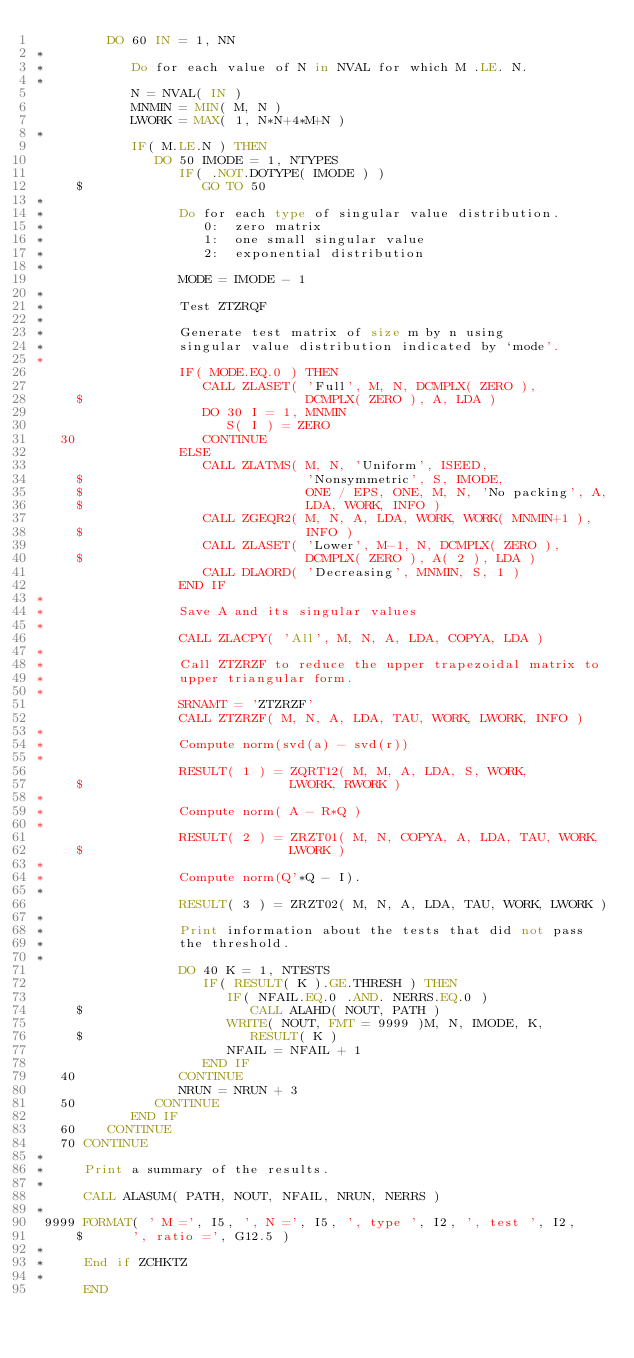<code> <loc_0><loc_0><loc_500><loc_500><_FORTRAN_>         DO 60 IN = 1, NN
*
*           Do for each value of N in NVAL for which M .LE. N.
*
            N = NVAL( IN )
            MNMIN = MIN( M, N )
            LWORK = MAX( 1, N*N+4*M+N )
*
            IF( M.LE.N ) THEN
               DO 50 IMODE = 1, NTYPES
                  IF( .NOT.DOTYPE( IMODE ) )
     $               GO TO 50
*
*                 Do for each type of singular value distribution.
*                    0:  zero matrix
*                    1:  one small singular value
*                    2:  exponential distribution
*
                  MODE = IMODE - 1
*
*                 Test ZTZRQF
*
*                 Generate test matrix of size m by n using
*                 singular value distribution indicated by `mode'.
*
                  IF( MODE.EQ.0 ) THEN
                     CALL ZLASET( 'Full', M, N, DCMPLX( ZERO ),
     $                            DCMPLX( ZERO ), A, LDA )
                     DO 30 I = 1, MNMIN
                        S( I ) = ZERO
   30                CONTINUE
                  ELSE
                     CALL ZLATMS( M, N, 'Uniform', ISEED,
     $                            'Nonsymmetric', S, IMODE,
     $                            ONE / EPS, ONE, M, N, 'No packing', A,
     $                            LDA, WORK, INFO )
                     CALL ZGEQR2( M, N, A, LDA, WORK, WORK( MNMIN+1 ),
     $                            INFO )
                     CALL ZLASET( 'Lower', M-1, N, DCMPLX( ZERO ),
     $                            DCMPLX( ZERO ), A( 2 ), LDA )
                     CALL DLAORD( 'Decreasing', MNMIN, S, 1 )
                  END IF
*
*                 Save A and its singular values
*
                  CALL ZLACPY( 'All', M, N, A, LDA, COPYA, LDA )
*
*                 Call ZTZRZF to reduce the upper trapezoidal matrix to
*                 upper triangular form.
*
                  SRNAMT = 'ZTZRZF'
                  CALL ZTZRZF( M, N, A, LDA, TAU, WORK, LWORK, INFO )
*
*                 Compute norm(svd(a) - svd(r))
*
                  RESULT( 1 ) = ZQRT12( M, M, A, LDA, S, WORK,
     $                          LWORK, RWORK )
*
*                 Compute norm( A - R*Q )
*
                  RESULT( 2 ) = ZRZT01( M, N, COPYA, A, LDA, TAU, WORK,
     $                          LWORK )
*
*                 Compute norm(Q'*Q - I).
*
                  RESULT( 3 ) = ZRZT02( M, N, A, LDA, TAU, WORK, LWORK )
*
*                 Print information about the tests that did not pass
*                 the threshold.
*
                  DO 40 K = 1, NTESTS
                     IF( RESULT( K ).GE.THRESH ) THEN
                        IF( NFAIL.EQ.0 .AND. NERRS.EQ.0 )
     $                     CALL ALAHD( NOUT, PATH )
                        WRITE( NOUT, FMT = 9999 )M, N, IMODE, K,
     $                     RESULT( K )
                        NFAIL = NFAIL + 1
                     END IF
   40             CONTINUE
                  NRUN = NRUN + 3
   50          CONTINUE
            END IF
   60    CONTINUE
   70 CONTINUE
*
*     Print a summary of the results.
*
      CALL ALASUM( PATH, NOUT, NFAIL, NRUN, NERRS )
*
 9999 FORMAT( ' M =', I5, ', N =', I5, ', type ', I2, ', test ', I2,
     $      ', ratio =', G12.5 )
*
*     End if ZCHKTZ
*
      END
</code> 